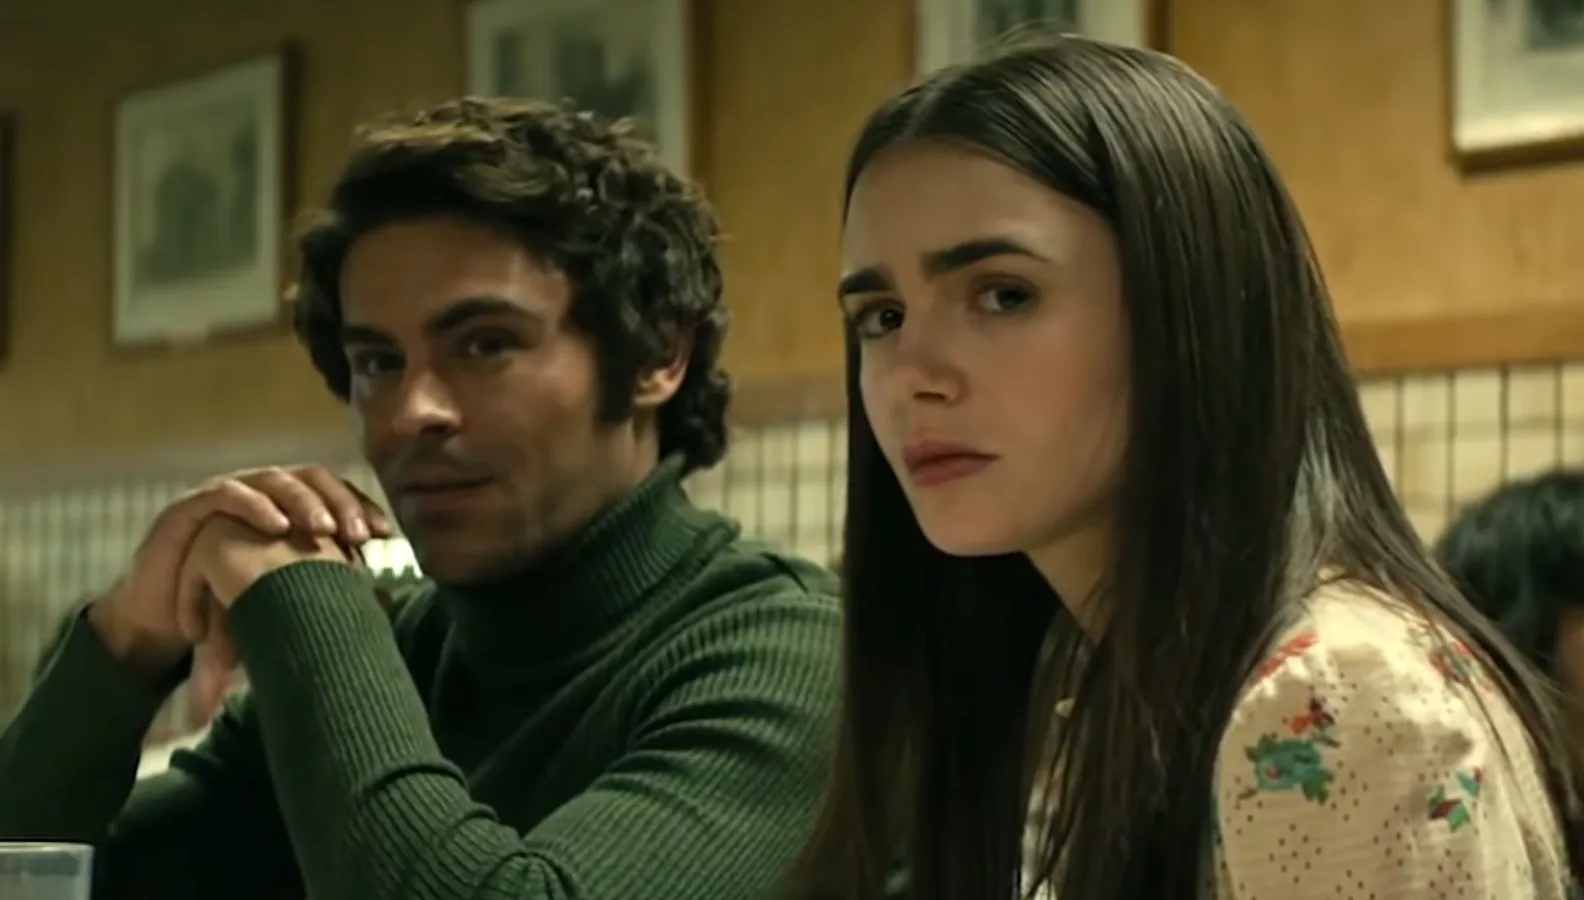What can you infer about the setting and time period of the scene? The setting appears to be an old-fashioned diner, which can be inferred from the checkered wall design and the framed pictures adorning the walls. These decorative elements, along with the traditional booth seating, suggest a mid-20th-century American diner. The sepia-toned images in the frames further enhance the nostalgic feel. The overall ambiance of the diner suggests it is a place where people come to engage in deep, personal conversations, adding a timeless quality to the scene. 